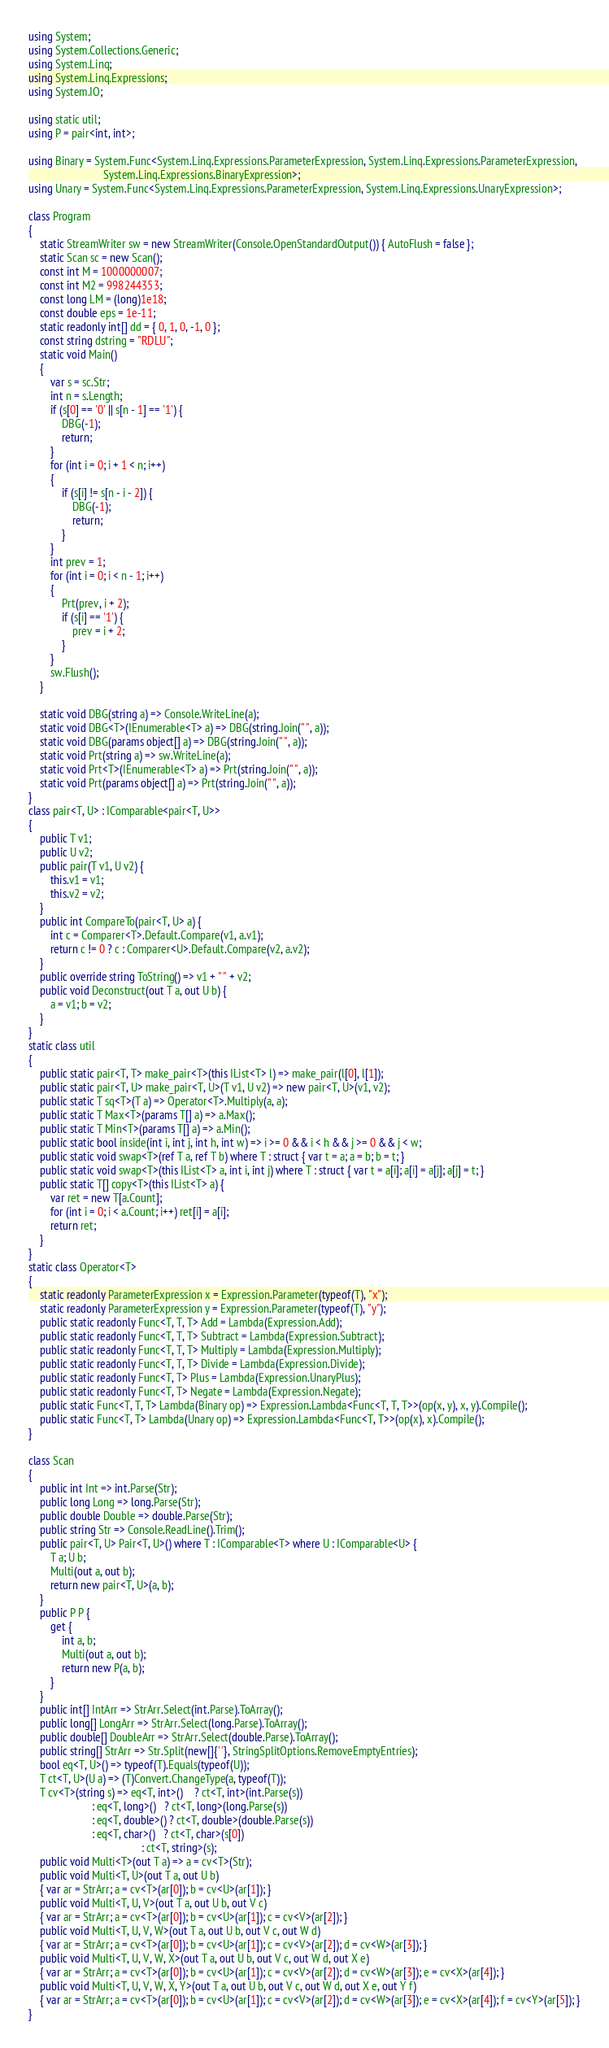<code> <loc_0><loc_0><loc_500><loc_500><_C#_>using System;
using System.Collections.Generic;
using System.Linq;
using System.Linq.Expressions;
using System.IO;

using static util;
using P = pair<int, int>;

using Binary = System.Func<System.Linq.Expressions.ParameterExpression, System.Linq.Expressions.ParameterExpression,
                           System.Linq.Expressions.BinaryExpression>;
using Unary = System.Func<System.Linq.Expressions.ParameterExpression, System.Linq.Expressions.UnaryExpression>;

class Program
{
    static StreamWriter sw = new StreamWriter(Console.OpenStandardOutput()) { AutoFlush = false };
    static Scan sc = new Scan();
    const int M = 1000000007;
    const int M2 = 998244353;
    const long LM = (long)1e18;
    const double eps = 1e-11;
    static readonly int[] dd = { 0, 1, 0, -1, 0 };
    const string dstring = "RDLU";
    static void Main()
    {
        var s = sc.Str;
        int n = s.Length;
        if (s[0] == '0' || s[n - 1] == '1') {
            DBG(-1);
            return;
        }
        for (int i = 0; i + 1 < n; i++)
        {
            if (s[i] != s[n - i - 2]) {
                DBG(-1);
                return;
            }
        }
        int prev = 1;
        for (int i = 0; i < n - 1; i++)
        {
            Prt(prev, i + 2);
            if (s[i] == '1') {
                prev = i + 2;
            }
        }
        sw.Flush();
    }

    static void DBG(string a) => Console.WriteLine(a);
    static void DBG<T>(IEnumerable<T> a) => DBG(string.Join(" ", a));
    static void DBG(params object[] a) => DBG(string.Join(" ", a));
    static void Prt(string a) => sw.WriteLine(a);
    static void Prt<T>(IEnumerable<T> a) => Prt(string.Join(" ", a));
    static void Prt(params object[] a) => Prt(string.Join(" ", a));
}
class pair<T, U> : IComparable<pair<T, U>>
{
    public T v1;
    public U v2;
    public pair(T v1, U v2) {
        this.v1 = v1;
        this.v2 = v2;
    }
    public int CompareTo(pair<T, U> a) {
        int c = Comparer<T>.Default.Compare(v1, a.v1);
        return c != 0 ? c : Comparer<U>.Default.Compare(v2, a.v2);
    }
    public override string ToString() => v1 + " " + v2;
    public void Deconstruct(out T a, out U b) {
        a = v1; b = v2;
    }
}
static class util
{
    public static pair<T, T> make_pair<T>(this IList<T> l) => make_pair(l[0], l[1]);
    public static pair<T, U> make_pair<T, U>(T v1, U v2) => new pair<T, U>(v1, v2);
    public static T sq<T>(T a) => Operator<T>.Multiply(a, a);
    public static T Max<T>(params T[] a) => a.Max();
    public static T Min<T>(params T[] a) => a.Min();
    public static bool inside(int i, int j, int h, int w) => i >= 0 && i < h && j >= 0 && j < w;
    public static void swap<T>(ref T a, ref T b) where T : struct { var t = a; a = b; b = t; }
    public static void swap<T>(this IList<T> a, int i, int j) where T : struct { var t = a[i]; a[i] = a[j]; a[j] = t; }
    public static T[] copy<T>(this IList<T> a) {
        var ret = new T[a.Count];
        for (int i = 0; i < a.Count; i++) ret[i] = a[i];
        return ret;
    }
}
static class Operator<T>
{
    static readonly ParameterExpression x = Expression.Parameter(typeof(T), "x");
    static readonly ParameterExpression y = Expression.Parameter(typeof(T), "y");
    public static readonly Func<T, T, T> Add = Lambda(Expression.Add);
    public static readonly Func<T, T, T> Subtract = Lambda(Expression.Subtract);
    public static readonly Func<T, T, T> Multiply = Lambda(Expression.Multiply);
    public static readonly Func<T, T, T> Divide = Lambda(Expression.Divide);
    public static readonly Func<T, T> Plus = Lambda(Expression.UnaryPlus);
    public static readonly Func<T, T> Negate = Lambda(Expression.Negate);
    public static Func<T, T, T> Lambda(Binary op) => Expression.Lambda<Func<T, T, T>>(op(x, y), x, y).Compile();
    public static Func<T, T> Lambda(Unary op) => Expression.Lambda<Func<T, T>>(op(x), x).Compile();
}

class Scan
{
    public int Int => int.Parse(Str);
    public long Long => long.Parse(Str);
    public double Double => double.Parse(Str);
    public string Str => Console.ReadLine().Trim();
    public pair<T, U> Pair<T, U>() where T : IComparable<T> where U : IComparable<U> {
        T a; U b;
        Multi(out a, out b);
        return new pair<T, U>(a, b);
    }
    public P P {
        get {
            int a, b;
            Multi(out a, out b);
            return new P(a, b);
        }
    }
    public int[] IntArr => StrArr.Select(int.Parse).ToArray();
    public long[] LongArr => StrArr.Select(long.Parse).ToArray();
    public double[] DoubleArr => StrArr.Select(double.Parse).ToArray();
    public string[] StrArr => Str.Split(new[]{' '}, StringSplitOptions.RemoveEmptyEntries);
    bool eq<T, U>() => typeof(T).Equals(typeof(U));
    T ct<T, U>(U a) => (T)Convert.ChangeType(a, typeof(T));
    T cv<T>(string s) => eq<T, int>()    ? ct<T, int>(int.Parse(s))
                       : eq<T, long>()   ? ct<T, long>(long.Parse(s))
                       : eq<T, double>() ? ct<T, double>(double.Parse(s))
                       : eq<T, char>()   ? ct<T, char>(s[0])
                                         : ct<T, string>(s);
    public void Multi<T>(out T a) => a = cv<T>(Str);
    public void Multi<T, U>(out T a, out U b)
    { var ar = StrArr; a = cv<T>(ar[0]); b = cv<U>(ar[1]); }
    public void Multi<T, U, V>(out T a, out U b, out V c)
    { var ar = StrArr; a = cv<T>(ar[0]); b = cv<U>(ar[1]); c = cv<V>(ar[2]); }
    public void Multi<T, U, V, W>(out T a, out U b, out V c, out W d)
    { var ar = StrArr; a = cv<T>(ar[0]); b = cv<U>(ar[1]); c = cv<V>(ar[2]); d = cv<W>(ar[3]); }
    public void Multi<T, U, V, W, X>(out T a, out U b, out V c, out W d, out X e)
    { var ar = StrArr; a = cv<T>(ar[0]); b = cv<U>(ar[1]); c = cv<V>(ar[2]); d = cv<W>(ar[3]); e = cv<X>(ar[4]); }
    public void Multi<T, U, V, W, X, Y>(out T a, out U b, out V c, out W d, out X e, out Y f)
    { var ar = StrArr; a = cv<T>(ar[0]); b = cv<U>(ar[1]); c = cv<V>(ar[2]); d = cv<W>(ar[3]); e = cv<X>(ar[4]); f = cv<Y>(ar[5]); }
}
</code> 